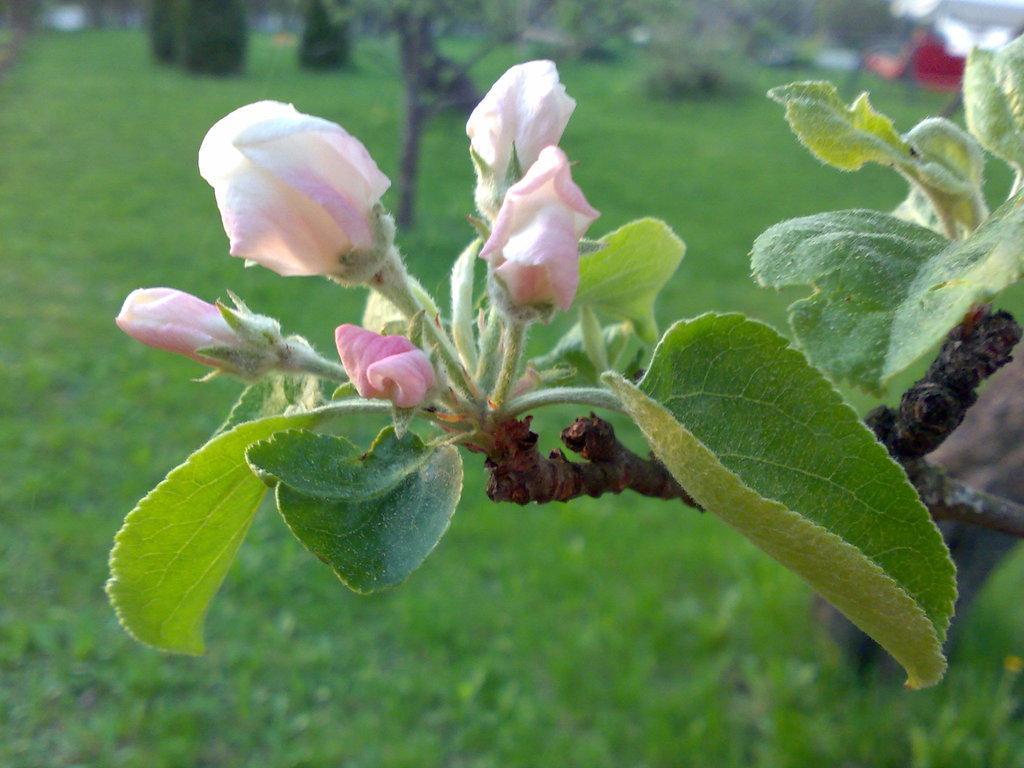Describe this image in one or two sentences. In this picture we can see flowers, trees, grass and in the background we can see some objects and it is blurry. 